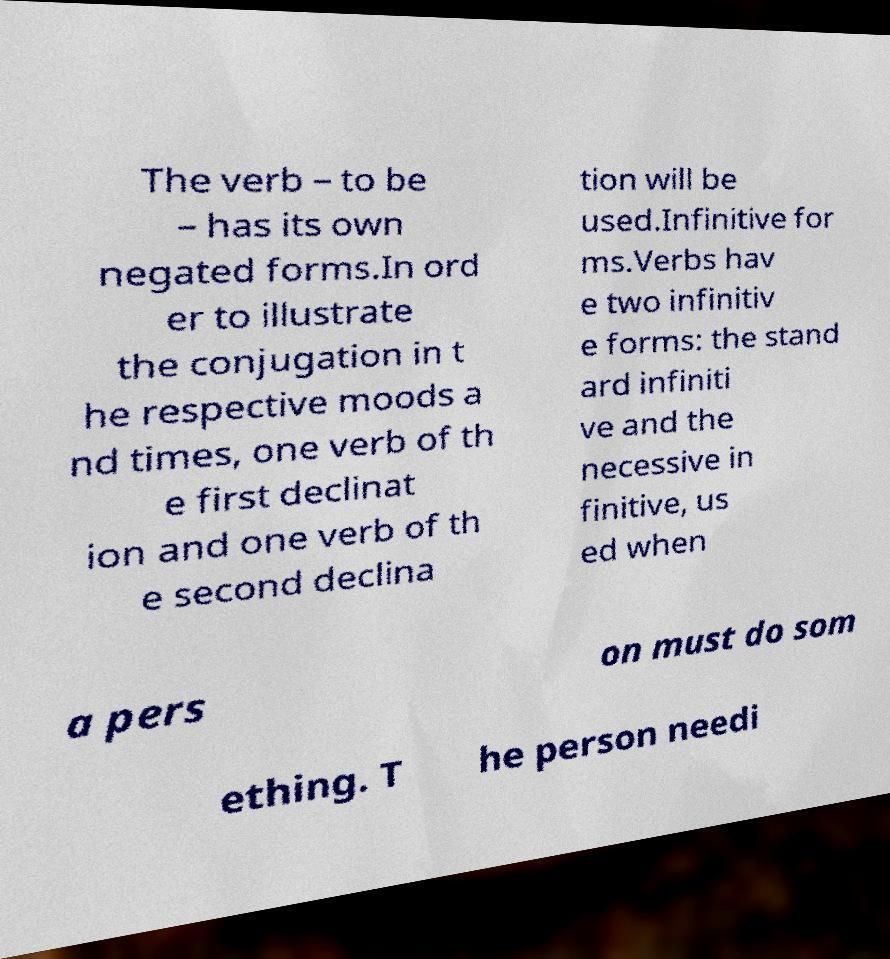Could you extract and type out the text from this image? The verb – to be – has its own negated forms.In ord er to illustrate the conjugation in t he respective moods a nd times, one verb of th e first declinat ion and one verb of th e second declina tion will be used.Infinitive for ms.Verbs hav e two infinitiv e forms: the stand ard infiniti ve and the necessive in finitive, us ed when a pers on must do som ething. T he person needi 